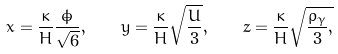<formula> <loc_0><loc_0><loc_500><loc_500>x = \frac { \kappa } { H } \frac { \dot { \phi } } { \sqrt { 6 } } , \quad y = \frac { \kappa } { H } \sqrt { \frac { U } { 3 } } , \quad z = \frac { \kappa } { H } \sqrt { \frac { \rho _ { \gamma } } { 3 } , }</formula> 